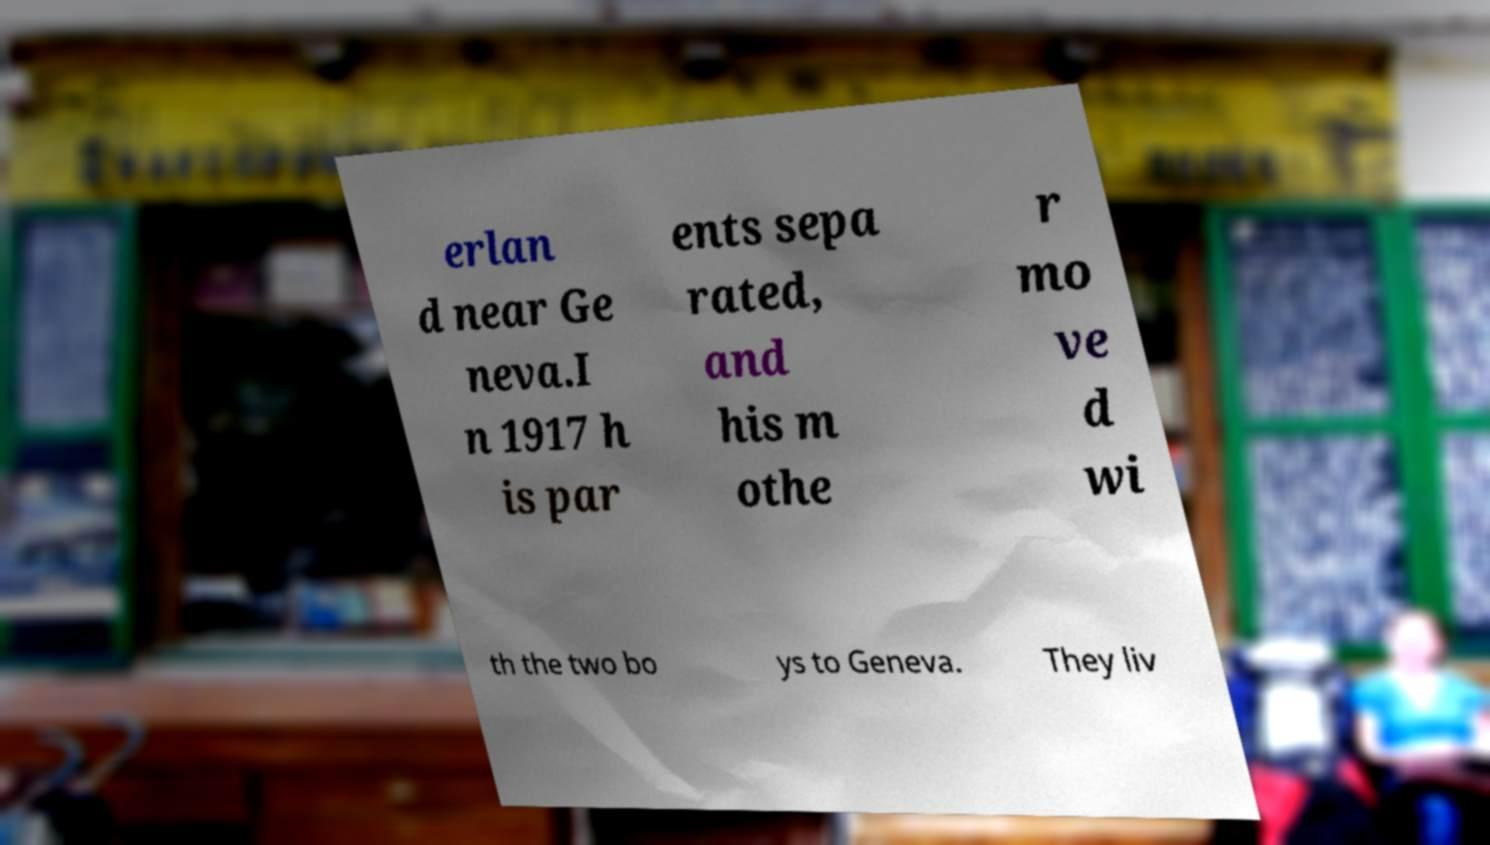There's text embedded in this image that I need extracted. Can you transcribe it verbatim? erlan d near Ge neva.I n 1917 h is par ents sepa rated, and his m othe r mo ve d wi th the two bo ys to Geneva. They liv 